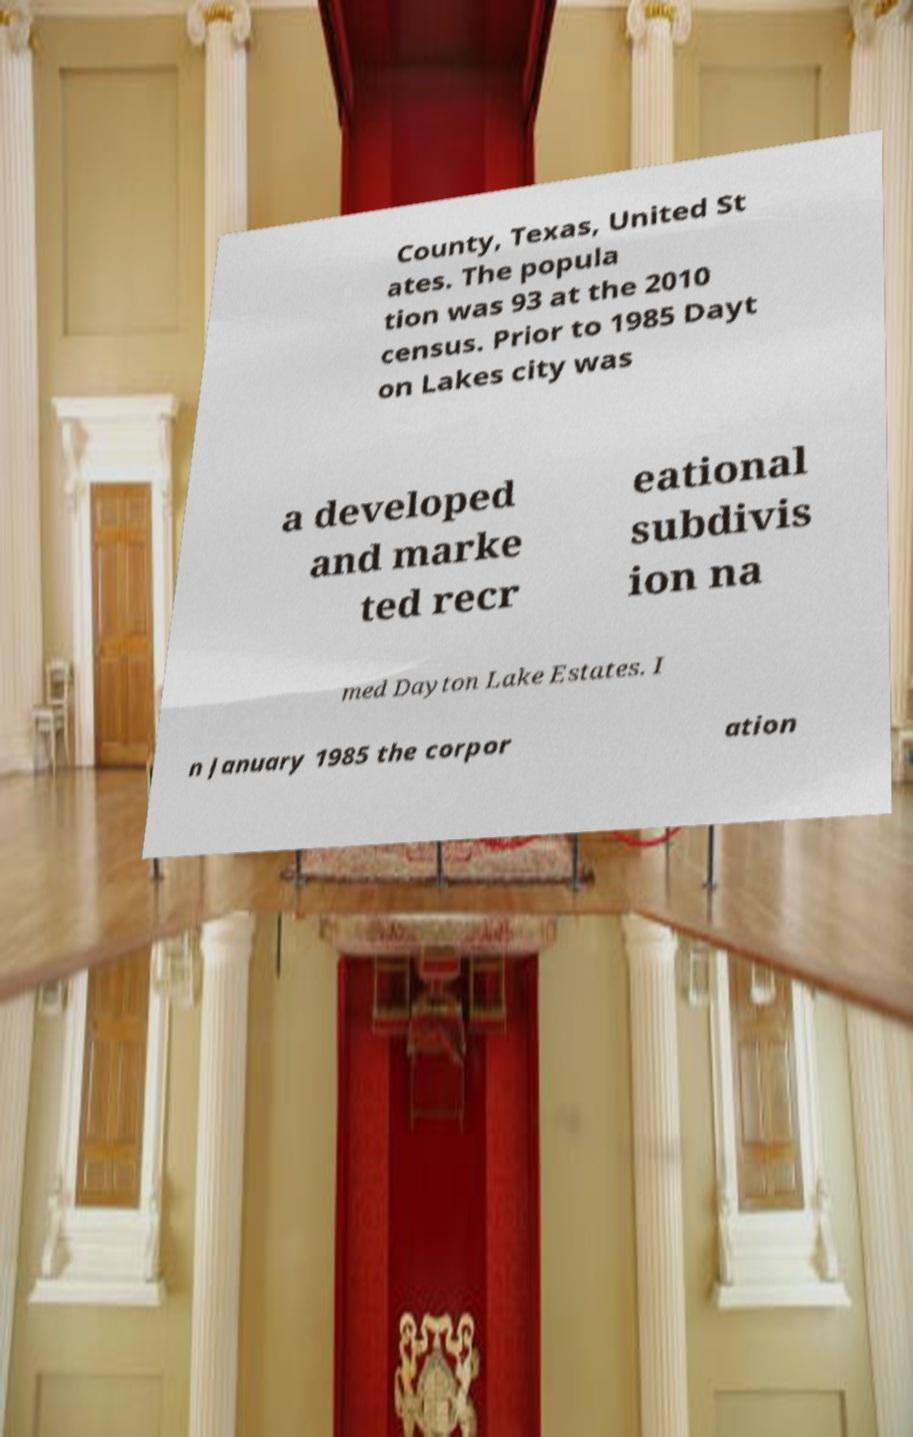Can you read and provide the text displayed in the image?This photo seems to have some interesting text. Can you extract and type it out for me? County, Texas, United St ates. The popula tion was 93 at the 2010 census. Prior to 1985 Dayt on Lakes city was a developed and marke ted recr eational subdivis ion na med Dayton Lake Estates. I n January 1985 the corpor ation 